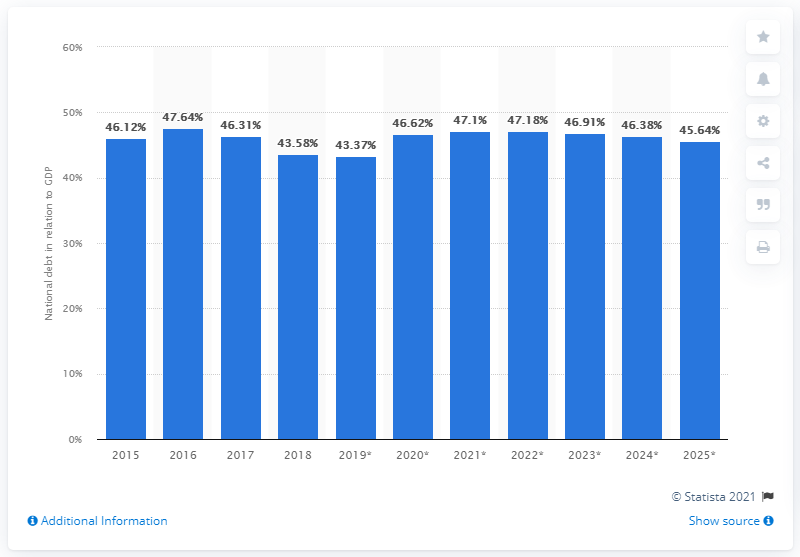Draw attention to some important aspects in this diagram. In 2018, the national debt of Vietnam accounted for 43.37% of the country's Gross Domestic Product (GDP). 